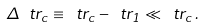<formula> <loc_0><loc_0><loc_500><loc_500>\Delta \ t r _ { c } \equiv \ t r _ { c } - \ t r _ { 1 } \ll \ t r _ { c } \, .</formula> 